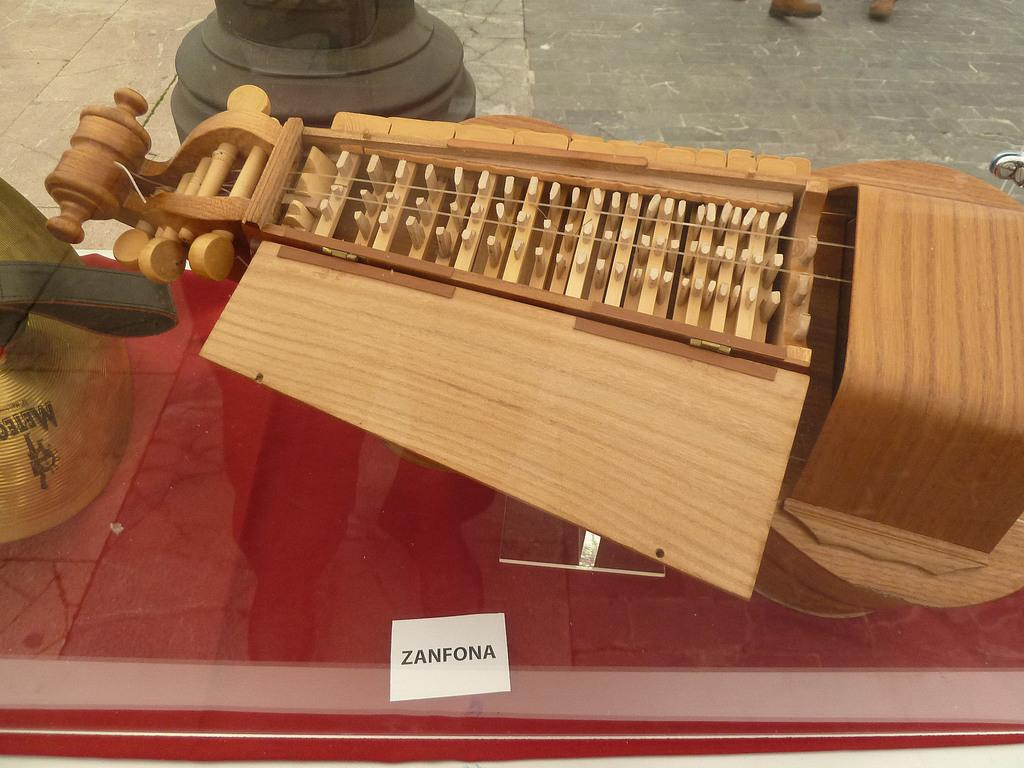What type of objects can be seen in the image? There are musical instruments in the image. What material are the musical instruments made of? The musical instruments are made from wood. What arithmetic problem is being solved by the women in the image? There are no women or arithmetic problems present in the image; it only features musical instruments made of wood. 